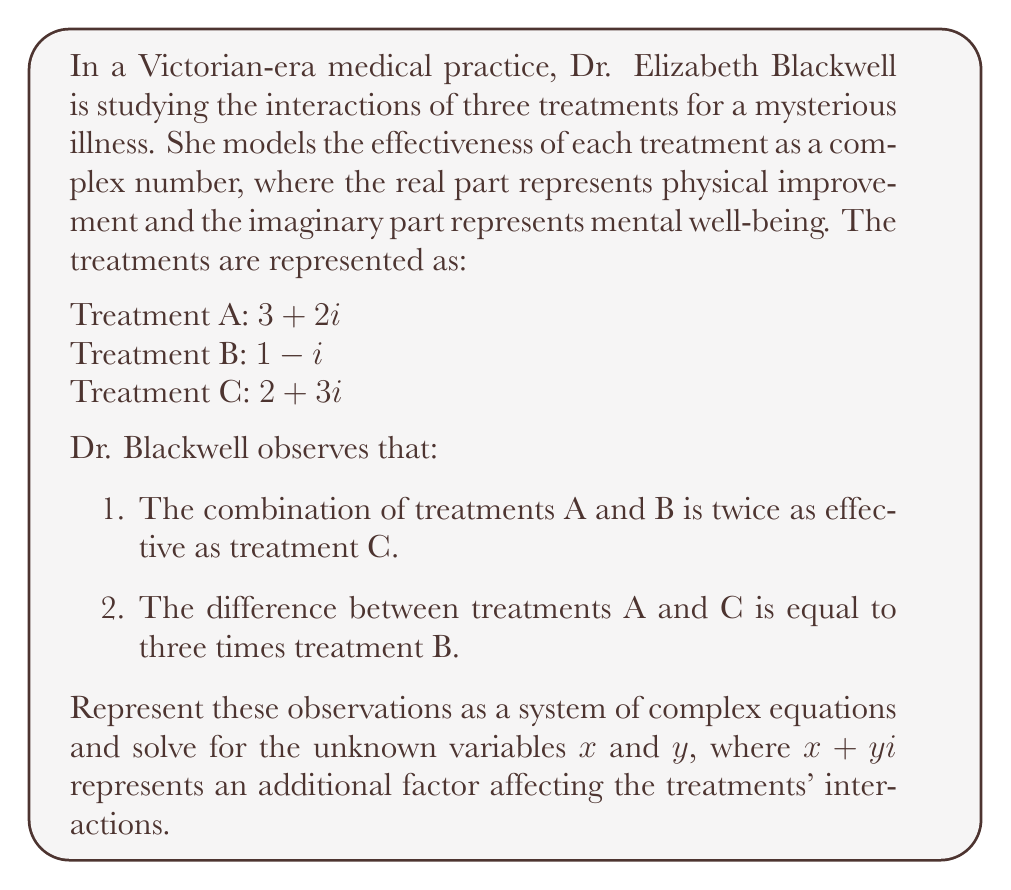Could you help me with this problem? Let's approach this problem step-by-step:

1) First, let's represent the observations as complex equations:

   Observation 1: $(3 + 2i + 1 - i)(x + yi) = 2(2 + 3i)$
   Observation 2: $(3 + 2i - (2 + 3i))(x + yi) = 3(1 - i)$

2) Let's simplify the left side of each equation:

   Equation 1: $(4 + i)(x + yi) = 4 + 6i$
   Equation 2: $(1 - i)(x + yi) = 3 - 3i$

3) Expand the left side of each equation:

   Equation 1: $4x + ix + 4yi - y = 4 + 6i$
   Equation 2: $x - yi + ix + y = 3 - 3i$

4) Separate real and imaginary parts:

   Equation 1: $4x - y = 4$ and $x + 4y = 6$
   Equation 2: $x + y = 3$ and $x - y = -3$

5) Now we have a system of four linear equations with two unknowns:

   $4x - y = 4$
   $x + 4y = 6$
   $x + y = 3$
   $x - y = -3$

6) We can solve this system by elimination. Let's add the third and fourth equations:

   $2x = 0$
   $x = 0$

7) Substitute $x = 0$ into the third equation:

   $0 + y = 3$
   $y = 3$

8) Therefore, the solution is $x = 0$ and $y = 3$.

9) We can verify this solution satisfies all four equations.
Answer: $x + yi = 0 + 3i$ 